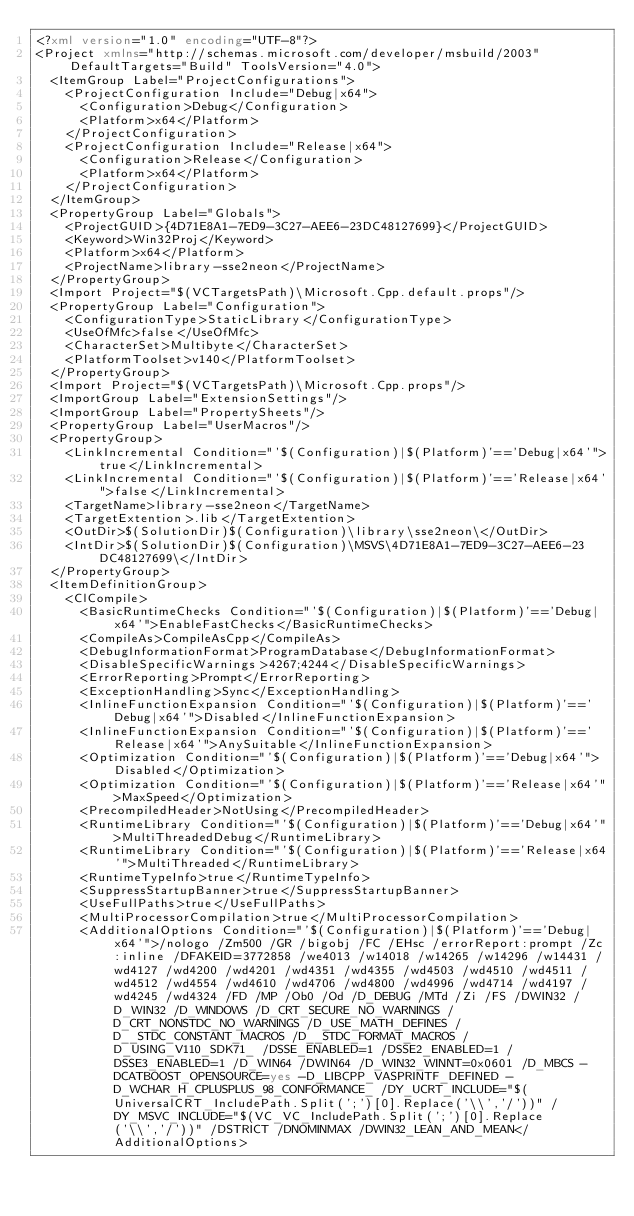<code> <loc_0><loc_0><loc_500><loc_500><_XML_><?xml version="1.0" encoding="UTF-8"?>
<Project xmlns="http://schemas.microsoft.com/developer/msbuild/2003" DefaultTargets="Build" ToolsVersion="4.0">
  <ItemGroup Label="ProjectConfigurations">
    <ProjectConfiguration Include="Debug|x64">
      <Configuration>Debug</Configuration>
      <Platform>x64</Platform>
    </ProjectConfiguration>
    <ProjectConfiguration Include="Release|x64">
      <Configuration>Release</Configuration>
      <Platform>x64</Platform>
    </ProjectConfiguration>
  </ItemGroup>
  <PropertyGroup Label="Globals">
    <ProjectGUID>{4D71E8A1-7ED9-3C27-AEE6-23DC48127699}</ProjectGUID>
    <Keyword>Win32Proj</Keyword>
    <Platform>x64</Platform>
    <ProjectName>library-sse2neon</ProjectName>
  </PropertyGroup>
  <Import Project="$(VCTargetsPath)\Microsoft.Cpp.default.props"/>
  <PropertyGroup Label="Configuration">
    <ConfigurationType>StaticLibrary</ConfigurationType>
    <UseOfMfc>false</UseOfMfc>
    <CharacterSet>Multibyte</CharacterSet>
    <PlatformToolset>v140</PlatformToolset>
  </PropertyGroup>
  <Import Project="$(VCTargetsPath)\Microsoft.Cpp.props"/>
  <ImportGroup Label="ExtensionSettings"/>
  <ImportGroup Label="PropertySheets"/>
  <PropertyGroup Label="UserMacros"/>
  <PropertyGroup>
    <LinkIncremental Condition="'$(Configuration)|$(Platform)'=='Debug|x64'">true</LinkIncremental>
    <LinkIncremental Condition="'$(Configuration)|$(Platform)'=='Release|x64'">false</LinkIncremental>
    <TargetName>library-sse2neon</TargetName>
    <TargetExtention>.lib</TargetExtention>
    <OutDir>$(SolutionDir)$(Configuration)\library\sse2neon\</OutDir>
    <IntDir>$(SolutionDir)$(Configuration)\MSVS\4D71E8A1-7ED9-3C27-AEE6-23DC48127699\</IntDir>
  </PropertyGroup>
  <ItemDefinitionGroup>
    <ClCompile>
      <BasicRuntimeChecks Condition="'$(Configuration)|$(Platform)'=='Debug|x64'">EnableFastChecks</BasicRuntimeChecks>
      <CompileAs>CompileAsCpp</CompileAs>
      <DebugInformationFormat>ProgramDatabase</DebugInformationFormat>
      <DisableSpecificWarnings>4267;4244</DisableSpecificWarnings>
      <ErrorReporting>Prompt</ErrorReporting>
      <ExceptionHandling>Sync</ExceptionHandling>
      <InlineFunctionExpansion Condition="'$(Configuration)|$(Platform)'=='Debug|x64'">Disabled</InlineFunctionExpansion>
      <InlineFunctionExpansion Condition="'$(Configuration)|$(Platform)'=='Release|x64'">AnySuitable</InlineFunctionExpansion>
      <Optimization Condition="'$(Configuration)|$(Platform)'=='Debug|x64'">Disabled</Optimization>
      <Optimization Condition="'$(Configuration)|$(Platform)'=='Release|x64'">MaxSpeed</Optimization>
      <PrecompiledHeader>NotUsing</PrecompiledHeader>
      <RuntimeLibrary Condition="'$(Configuration)|$(Platform)'=='Debug|x64'">MultiThreadedDebug</RuntimeLibrary>
      <RuntimeLibrary Condition="'$(Configuration)|$(Platform)'=='Release|x64'">MultiThreaded</RuntimeLibrary>
      <RuntimeTypeInfo>true</RuntimeTypeInfo>
      <SuppressStartupBanner>true</SuppressStartupBanner>
      <UseFullPaths>true</UseFullPaths>
      <MultiProcessorCompilation>true</MultiProcessorCompilation>
      <AdditionalOptions Condition="'$(Configuration)|$(Platform)'=='Debug|x64'">/nologo /Zm500 /GR /bigobj /FC /EHsc /errorReport:prompt /Zc:inline /DFAKEID=3772858 /we4013 /w14018 /w14265 /w14296 /w14431 /wd4127 /wd4200 /wd4201 /wd4351 /wd4355 /wd4503 /wd4510 /wd4511 /wd4512 /wd4554 /wd4610 /wd4706 /wd4800 /wd4996 /wd4714 /wd4197 /wd4245 /wd4324 /FD /MP /Ob0 /Od /D_DEBUG /MTd /Zi /FS /DWIN32 /D_WIN32 /D_WINDOWS /D_CRT_SECURE_NO_WARNINGS /D_CRT_NONSTDC_NO_WARNINGS /D_USE_MATH_DEFINES /D__STDC_CONSTANT_MACROS /D__STDC_FORMAT_MACROS /D_USING_V110_SDK71_ /DSSE_ENABLED=1 /DSSE2_ENABLED=1 /DSSE3_ENABLED=1 /D_WIN64 /DWIN64 /D_WIN32_WINNT=0x0601 /D_MBCS -DCATBOOST_OPENSOURCE=yes -D_LIBCPP_VASPRINTF_DEFINED -D_WCHAR_H_CPLUSPLUS_98_CONFORMANCE_ /DY_UCRT_INCLUDE="$(UniversalCRT_IncludePath.Split(';')[0].Replace('\\','/'))" /DY_MSVC_INCLUDE="$(VC_VC_IncludePath.Split(';')[0].Replace('\\','/'))" /DSTRICT /DNOMINMAX /DWIN32_LEAN_AND_MEAN</AdditionalOptions></code> 